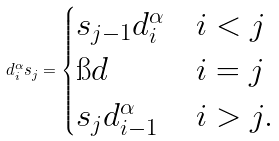<formula> <loc_0><loc_0><loc_500><loc_500>d _ { i } ^ { \alpha } s _ { j } = \begin{cases} s _ { j - 1 } d _ { i } ^ { \alpha } & i < j \\ \i d & i = j \\ s _ { j } d _ { i - 1 } ^ { \alpha } & i > j . \end{cases}</formula> 